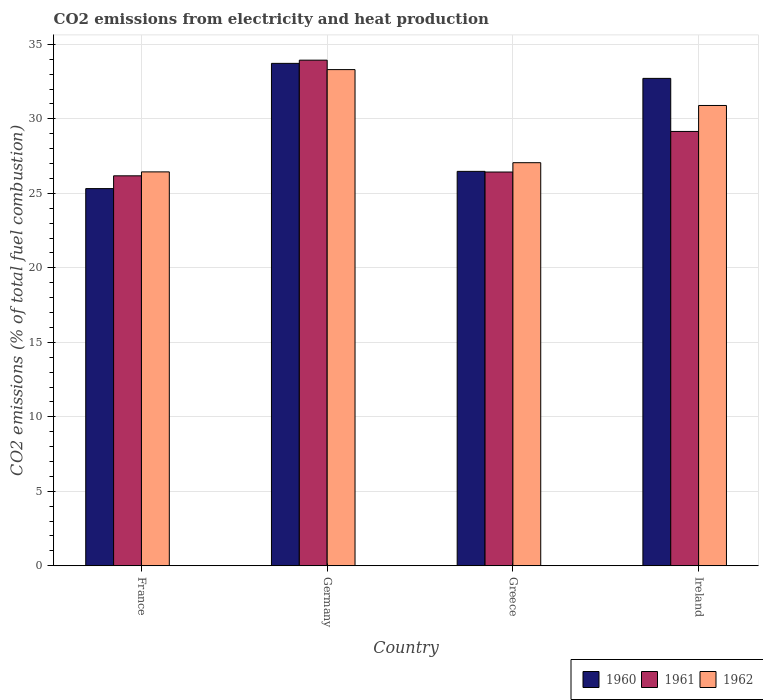How many groups of bars are there?
Your answer should be compact. 4. Are the number of bars on each tick of the X-axis equal?
Provide a succinct answer. Yes. What is the label of the 3rd group of bars from the left?
Give a very brief answer. Greece. In how many cases, is the number of bars for a given country not equal to the number of legend labels?
Your answer should be very brief. 0. What is the amount of CO2 emitted in 1962 in Greece?
Give a very brief answer. 27.06. Across all countries, what is the maximum amount of CO2 emitted in 1962?
Offer a very short reply. 33.31. Across all countries, what is the minimum amount of CO2 emitted in 1962?
Give a very brief answer. 26.44. In which country was the amount of CO2 emitted in 1960 maximum?
Offer a terse response. Germany. In which country was the amount of CO2 emitted in 1962 minimum?
Offer a very short reply. France. What is the total amount of CO2 emitted in 1960 in the graph?
Make the answer very short. 118.23. What is the difference between the amount of CO2 emitted in 1962 in Germany and that in Ireland?
Your answer should be very brief. 2.41. What is the difference between the amount of CO2 emitted in 1960 in Germany and the amount of CO2 emitted in 1961 in Greece?
Provide a short and direct response. 7.29. What is the average amount of CO2 emitted in 1960 per country?
Offer a terse response. 29.56. What is the difference between the amount of CO2 emitted of/in 1960 and amount of CO2 emitted of/in 1961 in France?
Your response must be concise. -0.86. What is the ratio of the amount of CO2 emitted in 1960 in Greece to that in Ireland?
Your response must be concise. 0.81. What is the difference between the highest and the second highest amount of CO2 emitted in 1960?
Give a very brief answer. -1.01. What is the difference between the highest and the lowest amount of CO2 emitted in 1962?
Your answer should be very brief. 6.87. In how many countries, is the amount of CO2 emitted in 1961 greater than the average amount of CO2 emitted in 1961 taken over all countries?
Ensure brevity in your answer.  2. Is the sum of the amount of CO2 emitted in 1962 in France and Germany greater than the maximum amount of CO2 emitted in 1961 across all countries?
Ensure brevity in your answer.  Yes. What does the 3rd bar from the left in Greece represents?
Make the answer very short. 1962. What does the 3rd bar from the right in Greece represents?
Provide a succinct answer. 1960. Is it the case that in every country, the sum of the amount of CO2 emitted in 1960 and amount of CO2 emitted in 1961 is greater than the amount of CO2 emitted in 1962?
Make the answer very short. Yes. What is the difference between two consecutive major ticks on the Y-axis?
Offer a terse response. 5. Are the values on the major ticks of Y-axis written in scientific E-notation?
Ensure brevity in your answer.  No. Does the graph contain any zero values?
Offer a very short reply. No. Does the graph contain grids?
Provide a short and direct response. Yes. Where does the legend appear in the graph?
Make the answer very short. Bottom right. How are the legend labels stacked?
Offer a very short reply. Horizontal. What is the title of the graph?
Keep it short and to the point. CO2 emissions from electricity and heat production. Does "1962" appear as one of the legend labels in the graph?
Keep it short and to the point. Yes. What is the label or title of the Y-axis?
Make the answer very short. CO2 emissions (% of total fuel combustion). What is the CO2 emissions (% of total fuel combustion) of 1960 in France?
Provide a short and direct response. 25.32. What is the CO2 emissions (% of total fuel combustion) of 1961 in France?
Your answer should be very brief. 26.18. What is the CO2 emissions (% of total fuel combustion) in 1962 in France?
Your answer should be very brief. 26.44. What is the CO2 emissions (% of total fuel combustion) of 1960 in Germany?
Give a very brief answer. 33.72. What is the CO2 emissions (% of total fuel combustion) of 1961 in Germany?
Offer a very short reply. 33.94. What is the CO2 emissions (% of total fuel combustion) in 1962 in Germany?
Offer a terse response. 33.31. What is the CO2 emissions (% of total fuel combustion) of 1960 in Greece?
Your answer should be compact. 26.47. What is the CO2 emissions (% of total fuel combustion) in 1961 in Greece?
Provide a succinct answer. 26.43. What is the CO2 emissions (% of total fuel combustion) in 1962 in Greece?
Your answer should be compact. 27.06. What is the CO2 emissions (% of total fuel combustion) of 1960 in Ireland?
Your answer should be compact. 32.72. What is the CO2 emissions (% of total fuel combustion) in 1961 in Ireland?
Provide a succinct answer. 29.15. What is the CO2 emissions (% of total fuel combustion) in 1962 in Ireland?
Keep it short and to the point. 30.9. Across all countries, what is the maximum CO2 emissions (% of total fuel combustion) of 1960?
Keep it short and to the point. 33.72. Across all countries, what is the maximum CO2 emissions (% of total fuel combustion) of 1961?
Offer a very short reply. 33.94. Across all countries, what is the maximum CO2 emissions (% of total fuel combustion) in 1962?
Your answer should be compact. 33.31. Across all countries, what is the minimum CO2 emissions (% of total fuel combustion) in 1960?
Provide a succinct answer. 25.32. Across all countries, what is the minimum CO2 emissions (% of total fuel combustion) of 1961?
Give a very brief answer. 26.18. Across all countries, what is the minimum CO2 emissions (% of total fuel combustion) of 1962?
Your answer should be very brief. 26.44. What is the total CO2 emissions (% of total fuel combustion) in 1960 in the graph?
Provide a succinct answer. 118.23. What is the total CO2 emissions (% of total fuel combustion) of 1961 in the graph?
Provide a short and direct response. 115.7. What is the total CO2 emissions (% of total fuel combustion) of 1962 in the graph?
Keep it short and to the point. 117.7. What is the difference between the CO2 emissions (% of total fuel combustion) in 1960 in France and that in Germany?
Keep it short and to the point. -8.41. What is the difference between the CO2 emissions (% of total fuel combustion) of 1961 in France and that in Germany?
Keep it short and to the point. -7.76. What is the difference between the CO2 emissions (% of total fuel combustion) of 1962 in France and that in Germany?
Provide a succinct answer. -6.87. What is the difference between the CO2 emissions (% of total fuel combustion) of 1960 in France and that in Greece?
Make the answer very short. -1.16. What is the difference between the CO2 emissions (% of total fuel combustion) in 1961 in France and that in Greece?
Give a very brief answer. -0.26. What is the difference between the CO2 emissions (% of total fuel combustion) of 1962 in France and that in Greece?
Provide a short and direct response. -0.62. What is the difference between the CO2 emissions (% of total fuel combustion) of 1960 in France and that in Ireland?
Keep it short and to the point. -7.4. What is the difference between the CO2 emissions (% of total fuel combustion) of 1961 in France and that in Ireland?
Your answer should be compact. -2.98. What is the difference between the CO2 emissions (% of total fuel combustion) in 1962 in France and that in Ireland?
Give a very brief answer. -4.46. What is the difference between the CO2 emissions (% of total fuel combustion) in 1960 in Germany and that in Greece?
Provide a short and direct response. 7.25. What is the difference between the CO2 emissions (% of total fuel combustion) of 1961 in Germany and that in Greece?
Make the answer very short. 7.51. What is the difference between the CO2 emissions (% of total fuel combustion) in 1962 in Germany and that in Greece?
Your answer should be very brief. 6.25. What is the difference between the CO2 emissions (% of total fuel combustion) in 1960 in Germany and that in Ireland?
Offer a very short reply. 1.01. What is the difference between the CO2 emissions (% of total fuel combustion) of 1961 in Germany and that in Ireland?
Offer a very short reply. 4.79. What is the difference between the CO2 emissions (% of total fuel combustion) of 1962 in Germany and that in Ireland?
Your answer should be compact. 2.41. What is the difference between the CO2 emissions (% of total fuel combustion) of 1960 in Greece and that in Ireland?
Ensure brevity in your answer.  -6.24. What is the difference between the CO2 emissions (% of total fuel combustion) of 1961 in Greece and that in Ireland?
Give a very brief answer. -2.72. What is the difference between the CO2 emissions (% of total fuel combustion) of 1962 in Greece and that in Ireland?
Your answer should be very brief. -3.84. What is the difference between the CO2 emissions (% of total fuel combustion) in 1960 in France and the CO2 emissions (% of total fuel combustion) in 1961 in Germany?
Keep it short and to the point. -8.62. What is the difference between the CO2 emissions (% of total fuel combustion) in 1960 in France and the CO2 emissions (% of total fuel combustion) in 1962 in Germany?
Keep it short and to the point. -7.99. What is the difference between the CO2 emissions (% of total fuel combustion) of 1961 in France and the CO2 emissions (% of total fuel combustion) of 1962 in Germany?
Your response must be concise. -7.13. What is the difference between the CO2 emissions (% of total fuel combustion) in 1960 in France and the CO2 emissions (% of total fuel combustion) in 1961 in Greece?
Provide a succinct answer. -1.11. What is the difference between the CO2 emissions (% of total fuel combustion) in 1960 in France and the CO2 emissions (% of total fuel combustion) in 1962 in Greece?
Offer a very short reply. -1.74. What is the difference between the CO2 emissions (% of total fuel combustion) in 1961 in France and the CO2 emissions (% of total fuel combustion) in 1962 in Greece?
Your answer should be compact. -0.88. What is the difference between the CO2 emissions (% of total fuel combustion) of 1960 in France and the CO2 emissions (% of total fuel combustion) of 1961 in Ireland?
Offer a terse response. -3.84. What is the difference between the CO2 emissions (% of total fuel combustion) in 1960 in France and the CO2 emissions (% of total fuel combustion) in 1962 in Ireland?
Provide a short and direct response. -5.58. What is the difference between the CO2 emissions (% of total fuel combustion) in 1961 in France and the CO2 emissions (% of total fuel combustion) in 1962 in Ireland?
Keep it short and to the point. -4.72. What is the difference between the CO2 emissions (% of total fuel combustion) of 1960 in Germany and the CO2 emissions (% of total fuel combustion) of 1961 in Greece?
Provide a short and direct response. 7.29. What is the difference between the CO2 emissions (% of total fuel combustion) of 1960 in Germany and the CO2 emissions (% of total fuel combustion) of 1962 in Greece?
Your answer should be compact. 6.67. What is the difference between the CO2 emissions (% of total fuel combustion) of 1961 in Germany and the CO2 emissions (% of total fuel combustion) of 1962 in Greece?
Provide a short and direct response. 6.88. What is the difference between the CO2 emissions (% of total fuel combustion) in 1960 in Germany and the CO2 emissions (% of total fuel combustion) in 1961 in Ireland?
Your response must be concise. 4.57. What is the difference between the CO2 emissions (% of total fuel combustion) in 1960 in Germany and the CO2 emissions (% of total fuel combustion) in 1962 in Ireland?
Provide a succinct answer. 2.83. What is the difference between the CO2 emissions (% of total fuel combustion) in 1961 in Germany and the CO2 emissions (% of total fuel combustion) in 1962 in Ireland?
Provide a succinct answer. 3.04. What is the difference between the CO2 emissions (% of total fuel combustion) of 1960 in Greece and the CO2 emissions (% of total fuel combustion) of 1961 in Ireland?
Your answer should be very brief. -2.68. What is the difference between the CO2 emissions (% of total fuel combustion) of 1960 in Greece and the CO2 emissions (% of total fuel combustion) of 1962 in Ireland?
Offer a terse response. -4.42. What is the difference between the CO2 emissions (% of total fuel combustion) of 1961 in Greece and the CO2 emissions (% of total fuel combustion) of 1962 in Ireland?
Provide a short and direct response. -4.47. What is the average CO2 emissions (% of total fuel combustion) of 1960 per country?
Your answer should be compact. 29.56. What is the average CO2 emissions (% of total fuel combustion) in 1961 per country?
Offer a very short reply. 28.93. What is the average CO2 emissions (% of total fuel combustion) in 1962 per country?
Offer a terse response. 29.43. What is the difference between the CO2 emissions (% of total fuel combustion) in 1960 and CO2 emissions (% of total fuel combustion) in 1961 in France?
Your answer should be compact. -0.86. What is the difference between the CO2 emissions (% of total fuel combustion) in 1960 and CO2 emissions (% of total fuel combustion) in 1962 in France?
Keep it short and to the point. -1.12. What is the difference between the CO2 emissions (% of total fuel combustion) of 1961 and CO2 emissions (% of total fuel combustion) of 1962 in France?
Your answer should be very brief. -0.26. What is the difference between the CO2 emissions (% of total fuel combustion) of 1960 and CO2 emissions (% of total fuel combustion) of 1961 in Germany?
Provide a short and direct response. -0.21. What is the difference between the CO2 emissions (% of total fuel combustion) in 1960 and CO2 emissions (% of total fuel combustion) in 1962 in Germany?
Provide a short and direct response. 0.42. What is the difference between the CO2 emissions (% of total fuel combustion) in 1961 and CO2 emissions (% of total fuel combustion) in 1962 in Germany?
Ensure brevity in your answer.  0.63. What is the difference between the CO2 emissions (% of total fuel combustion) in 1960 and CO2 emissions (% of total fuel combustion) in 1961 in Greece?
Offer a terse response. 0.04. What is the difference between the CO2 emissions (% of total fuel combustion) in 1960 and CO2 emissions (% of total fuel combustion) in 1962 in Greece?
Offer a very short reply. -0.58. What is the difference between the CO2 emissions (% of total fuel combustion) in 1961 and CO2 emissions (% of total fuel combustion) in 1962 in Greece?
Provide a short and direct response. -0.63. What is the difference between the CO2 emissions (% of total fuel combustion) in 1960 and CO2 emissions (% of total fuel combustion) in 1961 in Ireland?
Provide a succinct answer. 3.56. What is the difference between the CO2 emissions (% of total fuel combustion) of 1960 and CO2 emissions (% of total fuel combustion) of 1962 in Ireland?
Offer a very short reply. 1.82. What is the difference between the CO2 emissions (% of total fuel combustion) of 1961 and CO2 emissions (% of total fuel combustion) of 1962 in Ireland?
Give a very brief answer. -1.74. What is the ratio of the CO2 emissions (% of total fuel combustion) of 1960 in France to that in Germany?
Your answer should be very brief. 0.75. What is the ratio of the CO2 emissions (% of total fuel combustion) of 1961 in France to that in Germany?
Provide a succinct answer. 0.77. What is the ratio of the CO2 emissions (% of total fuel combustion) in 1962 in France to that in Germany?
Ensure brevity in your answer.  0.79. What is the ratio of the CO2 emissions (% of total fuel combustion) in 1960 in France to that in Greece?
Your answer should be very brief. 0.96. What is the ratio of the CO2 emissions (% of total fuel combustion) of 1961 in France to that in Greece?
Keep it short and to the point. 0.99. What is the ratio of the CO2 emissions (% of total fuel combustion) in 1962 in France to that in Greece?
Ensure brevity in your answer.  0.98. What is the ratio of the CO2 emissions (% of total fuel combustion) in 1960 in France to that in Ireland?
Make the answer very short. 0.77. What is the ratio of the CO2 emissions (% of total fuel combustion) in 1961 in France to that in Ireland?
Provide a short and direct response. 0.9. What is the ratio of the CO2 emissions (% of total fuel combustion) of 1962 in France to that in Ireland?
Your response must be concise. 0.86. What is the ratio of the CO2 emissions (% of total fuel combustion) in 1960 in Germany to that in Greece?
Your answer should be compact. 1.27. What is the ratio of the CO2 emissions (% of total fuel combustion) in 1961 in Germany to that in Greece?
Provide a succinct answer. 1.28. What is the ratio of the CO2 emissions (% of total fuel combustion) of 1962 in Germany to that in Greece?
Offer a very short reply. 1.23. What is the ratio of the CO2 emissions (% of total fuel combustion) in 1960 in Germany to that in Ireland?
Offer a very short reply. 1.03. What is the ratio of the CO2 emissions (% of total fuel combustion) of 1961 in Germany to that in Ireland?
Your answer should be very brief. 1.16. What is the ratio of the CO2 emissions (% of total fuel combustion) in 1962 in Germany to that in Ireland?
Your answer should be compact. 1.08. What is the ratio of the CO2 emissions (% of total fuel combustion) of 1960 in Greece to that in Ireland?
Ensure brevity in your answer.  0.81. What is the ratio of the CO2 emissions (% of total fuel combustion) in 1961 in Greece to that in Ireland?
Provide a succinct answer. 0.91. What is the ratio of the CO2 emissions (% of total fuel combustion) of 1962 in Greece to that in Ireland?
Provide a short and direct response. 0.88. What is the difference between the highest and the second highest CO2 emissions (% of total fuel combustion) in 1960?
Provide a succinct answer. 1.01. What is the difference between the highest and the second highest CO2 emissions (% of total fuel combustion) in 1961?
Your answer should be very brief. 4.79. What is the difference between the highest and the second highest CO2 emissions (% of total fuel combustion) of 1962?
Provide a succinct answer. 2.41. What is the difference between the highest and the lowest CO2 emissions (% of total fuel combustion) of 1960?
Offer a very short reply. 8.41. What is the difference between the highest and the lowest CO2 emissions (% of total fuel combustion) of 1961?
Your response must be concise. 7.76. What is the difference between the highest and the lowest CO2 emissions (% of total fuel combustion) in 1962?
Give a very brief answer. 6.87. 